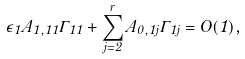<formula> <loc_0><loc_0><loc_500><loc_500>\epsilon _ { 1 } A _ { 1 , 1 1 } \Gamma _ { 1 1 } + \sum _ { j = 2 } ^ { r } A _ { 0 , 1 j } \Gamma _ { 1 j } = O ( 1 ) ,</formula> 